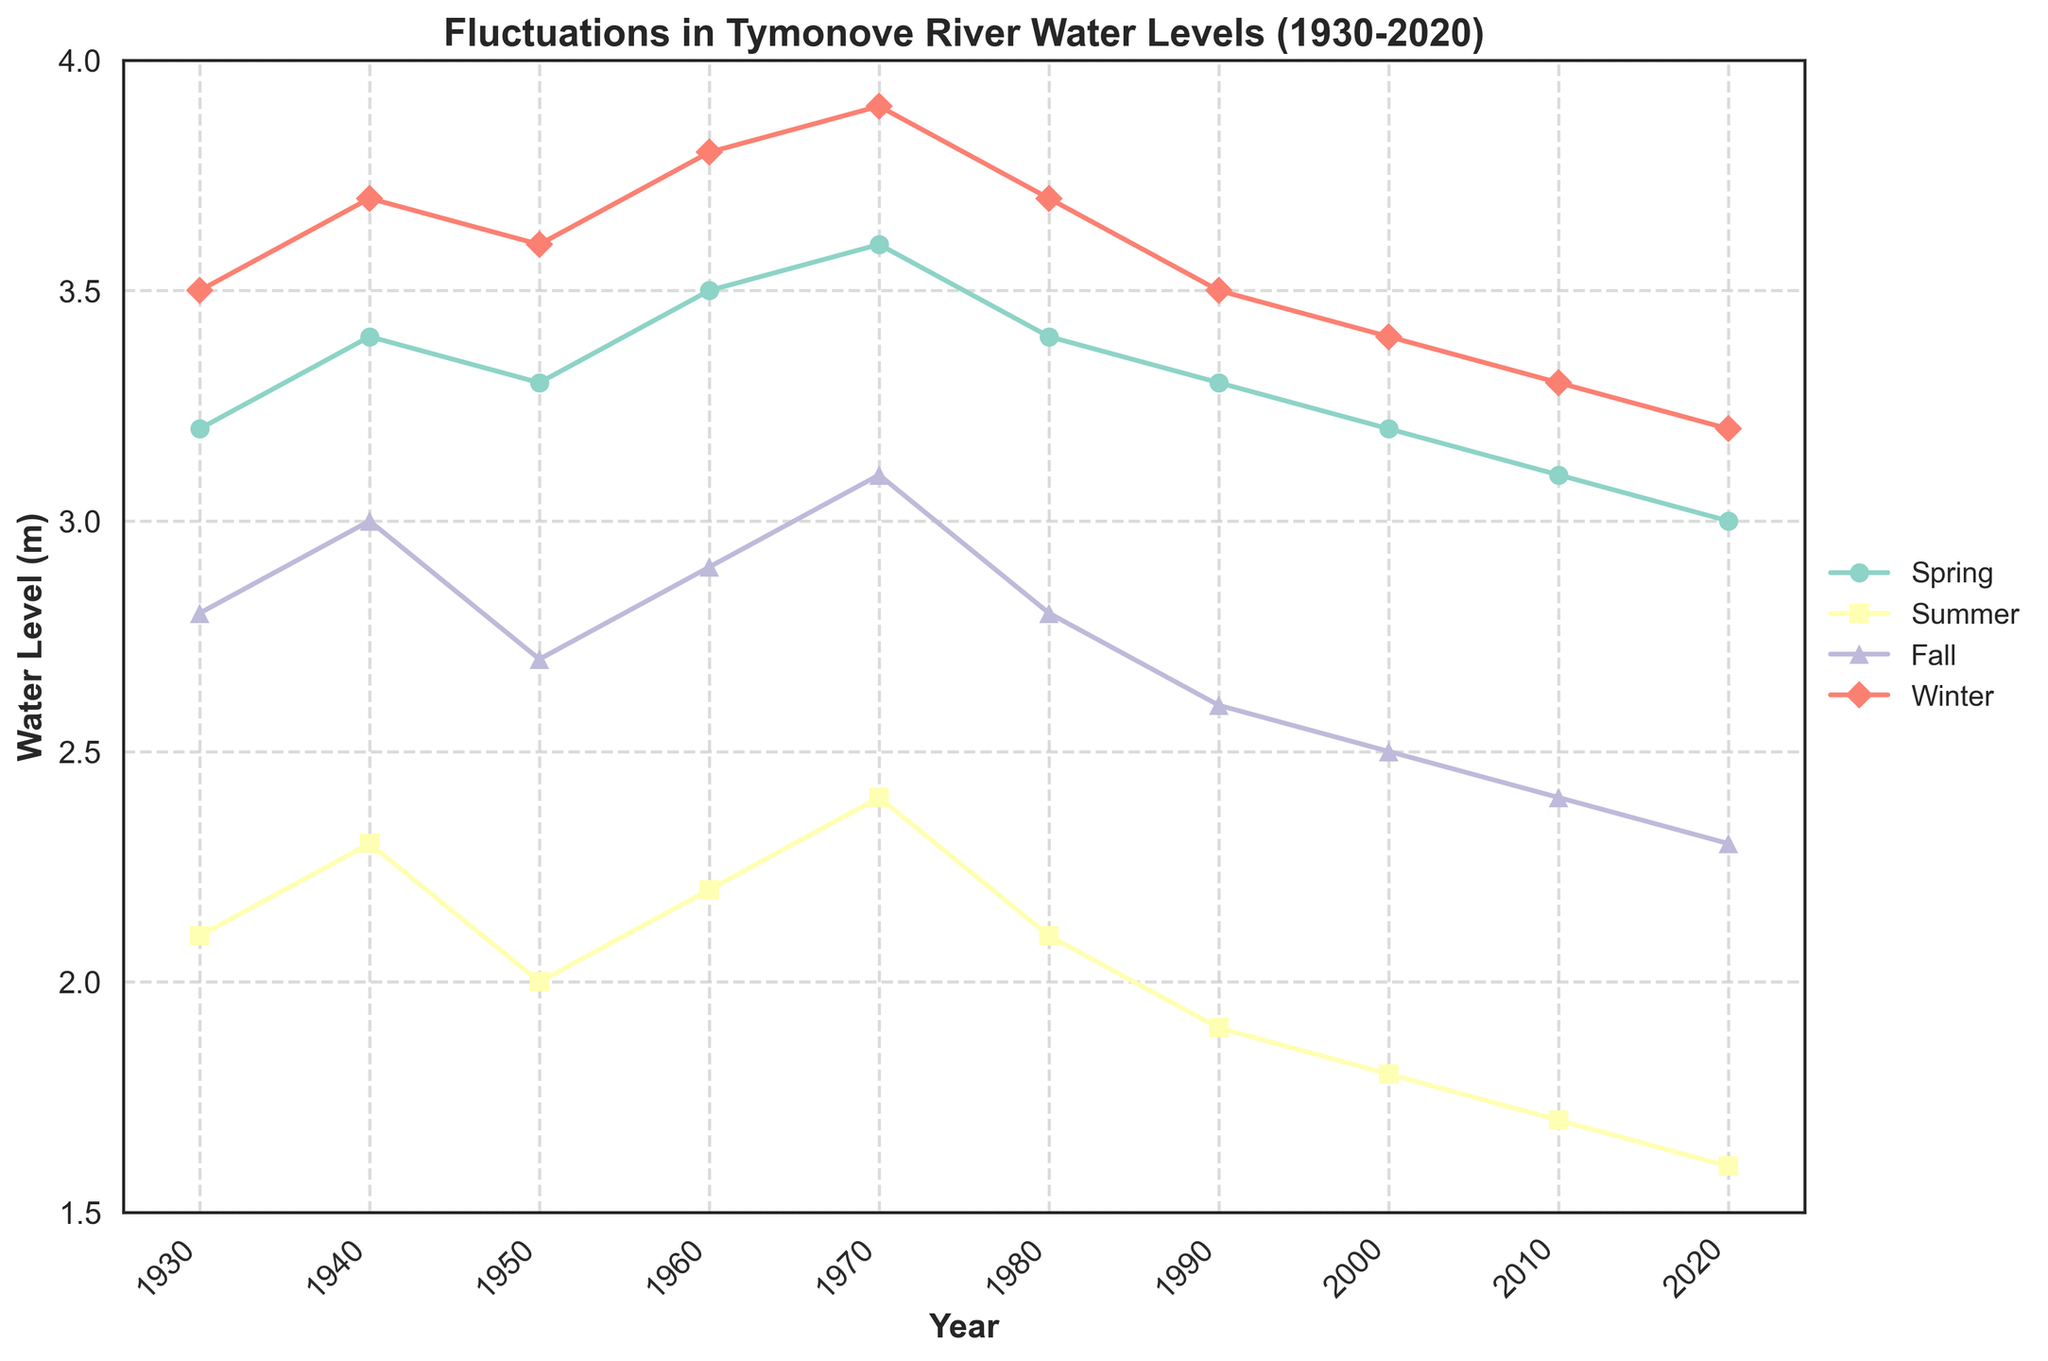Which season showed the highest water level in 1930? The water levels for 1930 are Spring: 3.2, Summer: 2.1, Fall: 2.8, and Winter: 3.5. The highest level is in Winter at 3.5 meters.
Answer: Winter In which year did the summer water level reach its minimum value? The summer water levels over the years are 2.1, 2.3, 2.0, 2.2, 2.4, 2.1, 1.9, 1.8, 1.7, and 1.6. The minimum value is 1.6, which occurred in 2020.
Answer: 2020 What is the average water level during Spring from 1930 to 2020? Spring water levels are 3.2, 3.4, 3.3, 3.5, 3.6, 3.4, 3.3, 3.2, 3.1, and 3.0. Summing these gives 33.0, and the average is 33.0 / 10 = 3.3 meters.
Answer: 3.3 Between 1960 and 1970, which season showed the greatest increase in water level? For 1960 and 1970, Spring increased from 3.5 to 3.6 (0.1), Summer from 2.2 to 2.4 (0.2), Fall from 2.9 to 3.1 (0.2), and Winter from 3.8 to 3.9 (0.1). Both Summer and Fall had the greatest increase of 0.2 meters.
Answer: Summer and Fall Which season had the largest overall decline in water levels from 1930 to 2020? The changes from 1930 to 2020 are Spring: 3.2 to 3.0 (-0.2), Summer: 2.1 to 1.6 (-0.5), Fall: 2.8 to 2.3 (-0.5), Winter: 3.5 to 3.2 (-0.3). Summer and Fall had the largest decline of -0.5 meters.
Answer: Summer and Fall What is the water level trend for Fall season from 1930 to 2020? The fall water levels decrease over time from 2.8 in 1930 to 2.3 in 2020. This is a consistent downward trend over the years.
Answer: Decreasing Which year shows the highest water level during the Spring season? Spring water levels are 3.2, 3.4, 3.3, 3.5, 3.6, 3.4, 3.3, 3.2, 3.1, and 3.0. The highest is 3.6, which is in 1970.
Answer: 1970 Compare the water levels of Winter and Summer in 1980. Which season has a higher level and by how much? In 1980, Winter's level is 3.7 and Summer's is 2.1. The difference is 3.7 - 2.1 = 1.6 meters. Winter has the higher level by 1.6 meters.
Answer: Winter by 1.6 meters What is the difference in the average water levels of Spring and Fall from 1930 to 2020? Average for Spring is (33.0 / 10) = 3.3. Average for Fall is (27.6 / 10) = 2.76. The difference is 3.3 - 2.76 = 0.54 meters.
Answer: 0.54 meters Which season saw the most variation in water levels from 1930 to 2020? The water levels variability can be seen by the ranges: Spring (3.6 - 3.0 = 0.6), Summer (2.4 - 1.6 = 0.8), Fall (3.1 - 2.3 = 0.8), Winter (3.9 - 3.2 = 0.7). Both Summer and Fall have the most variation, each being 0.8 meters.
Answer: Summer and Fall 